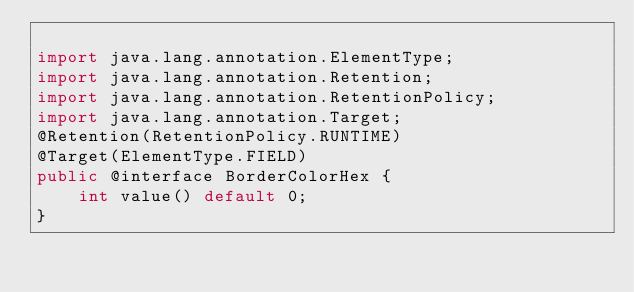Convert code to text. <code><loc_0><loc_0><loc_500><loc_500><_Java_>
import java.lang.annotation.ElementType;
import java.lang.annotation.Retention;
import java.lang.annotation.RetentionPolicy;
import java.lang.annotation.Target;
@Retention(RetentionPolicy.RUNTIME)
@Target(ElementType.FIELD)
public @interface BorderColorHex {
    int value() default 0;
}</code> 